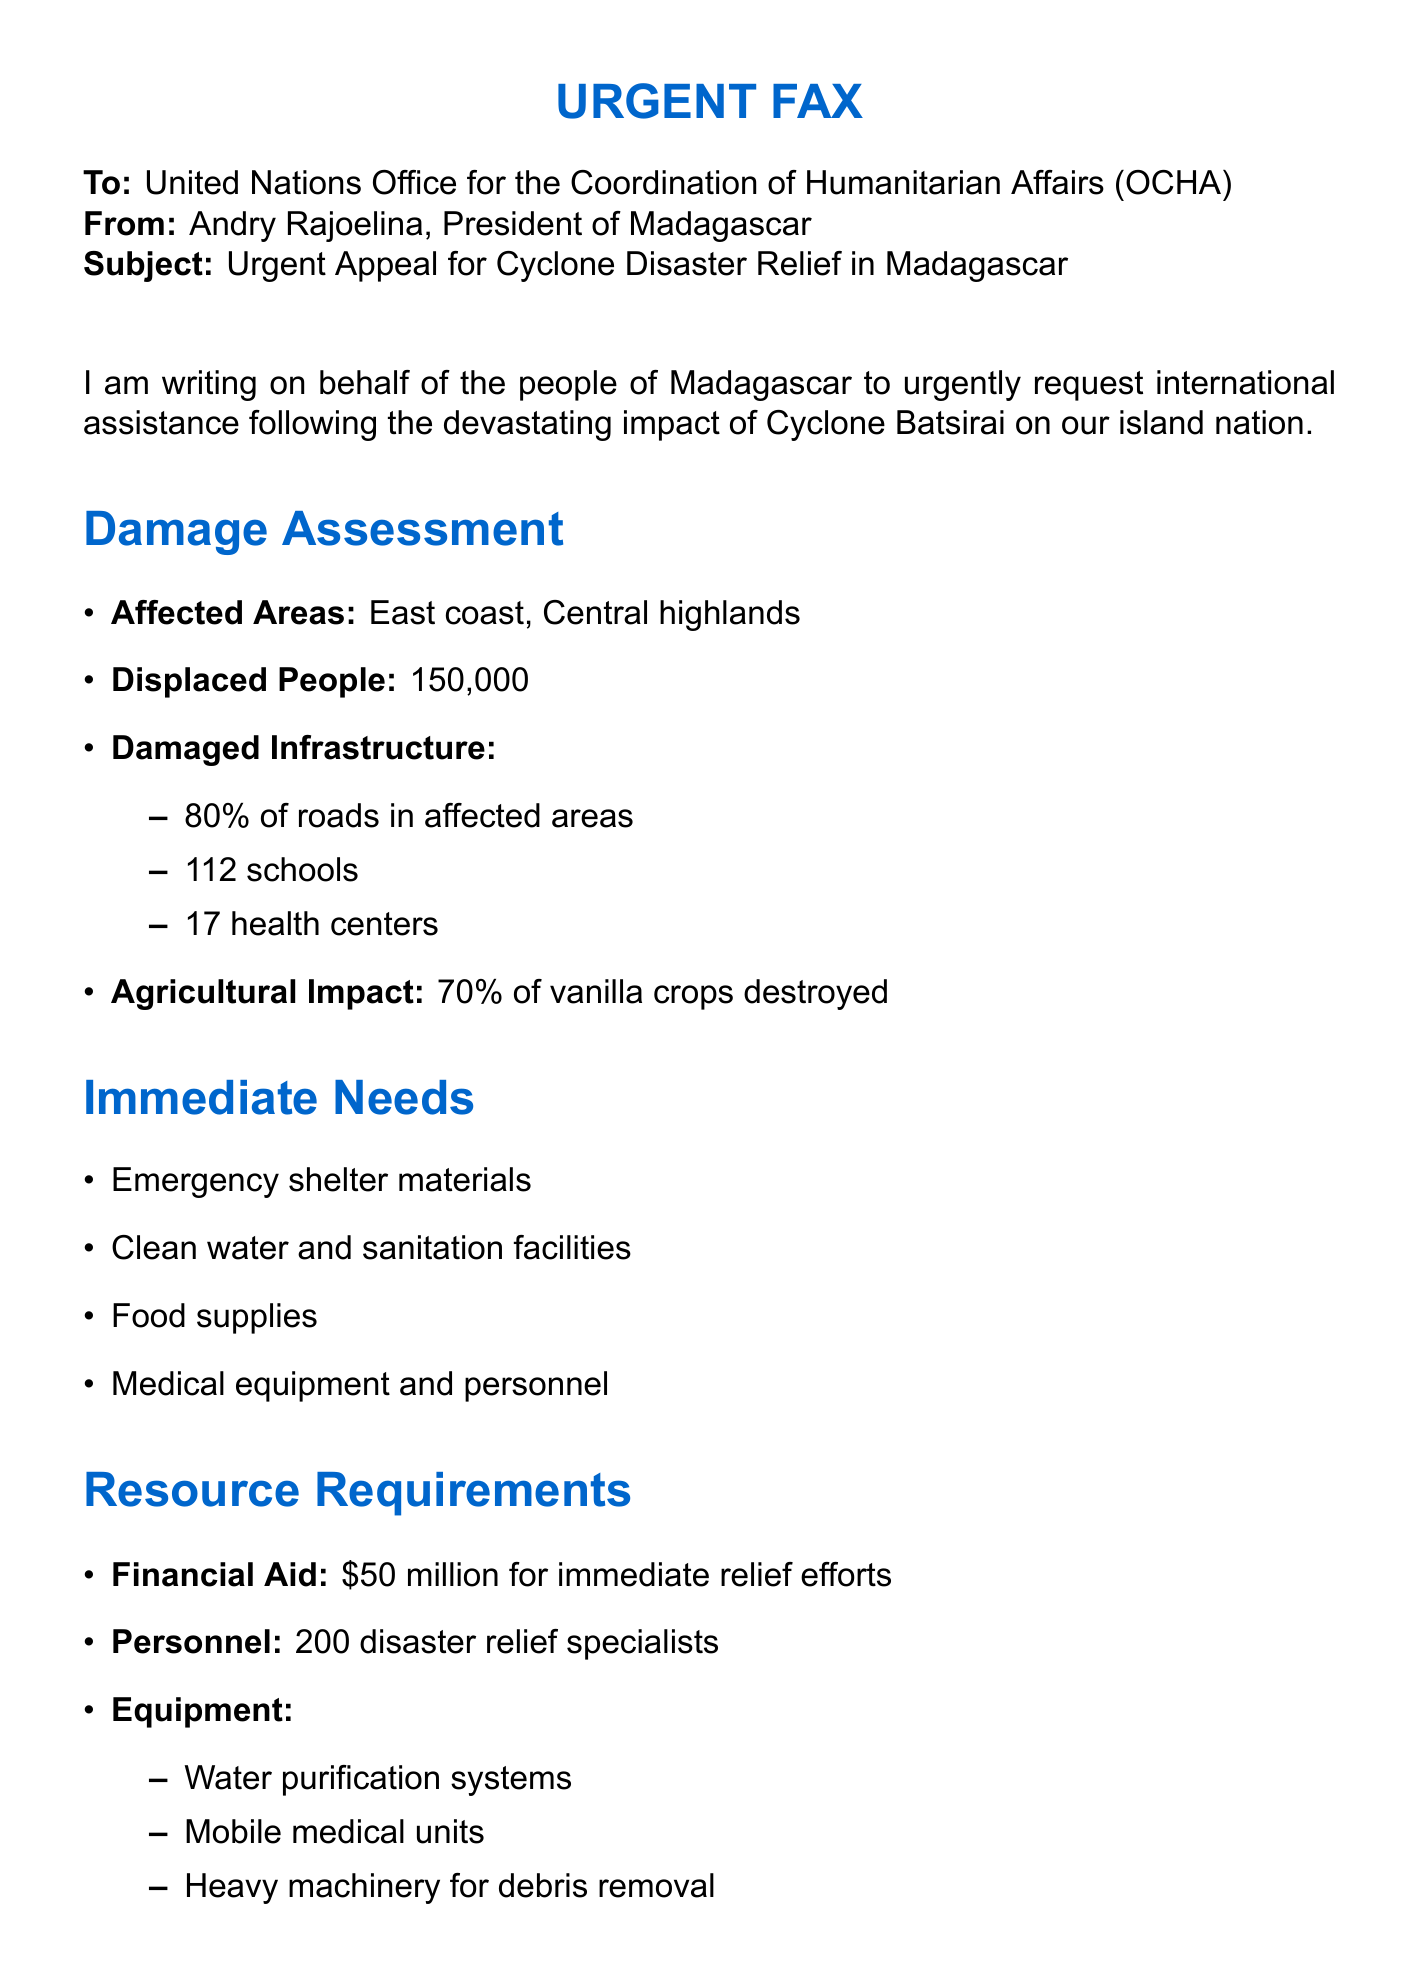What is the name of the cyclone mentioned? The document refers to "Cyclone Batsirai" as the event that prompted the appeal.
Answer: Cyclone Batsirai How many people have been displaced? The number of displaced people due to the cyclone is explicitly mentioned in the document.
Answer: 150,000 What percentage of roads are damaged in the affected areas? The damage assessment provides a specific percentage of roads that are affected.
Answer: 80% What is the required financial aid amount? The document states the amount needed for immediate relief efforts.
Answer: $50 million How many disaster relief specialists are needed? The document specifies the number of personnel required for relief efforts.
Answer: 200 What are the affected areas mentioned in the document? Two geographic locations are noted as areas impacted by the cyclone.
Answer: East coast, Central highlands What is one of the types of equipment needed? The document lists specific types of equipment required for disaster response.
Answer: Water purification systems What is the agricultural impact mentioned? The assessment addresses the impact on a specific crop due to the cyclone.
Answer: 70% of vanilla crops destroyed What type of document is this? The document is formatted and labeled to be a specific type of communication for urgent appeals.
Answer: Fax 